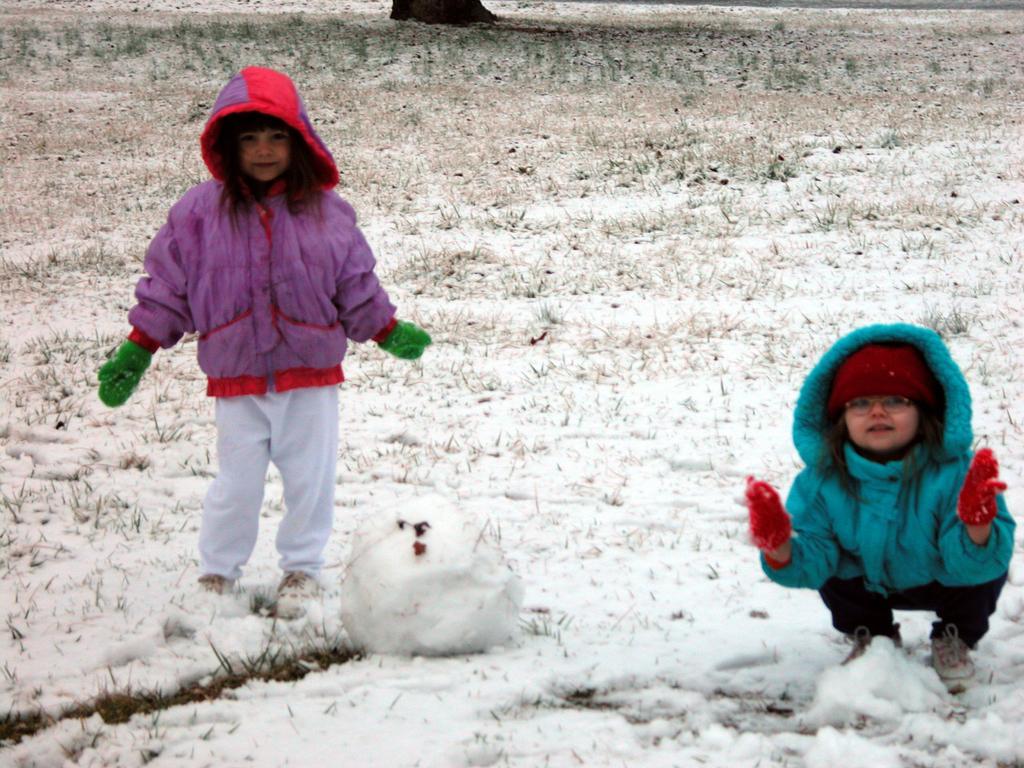Please provide a concise description of this image. In this image, I can see a girl standing and another girl in squat position. I can see the grass and snow. 